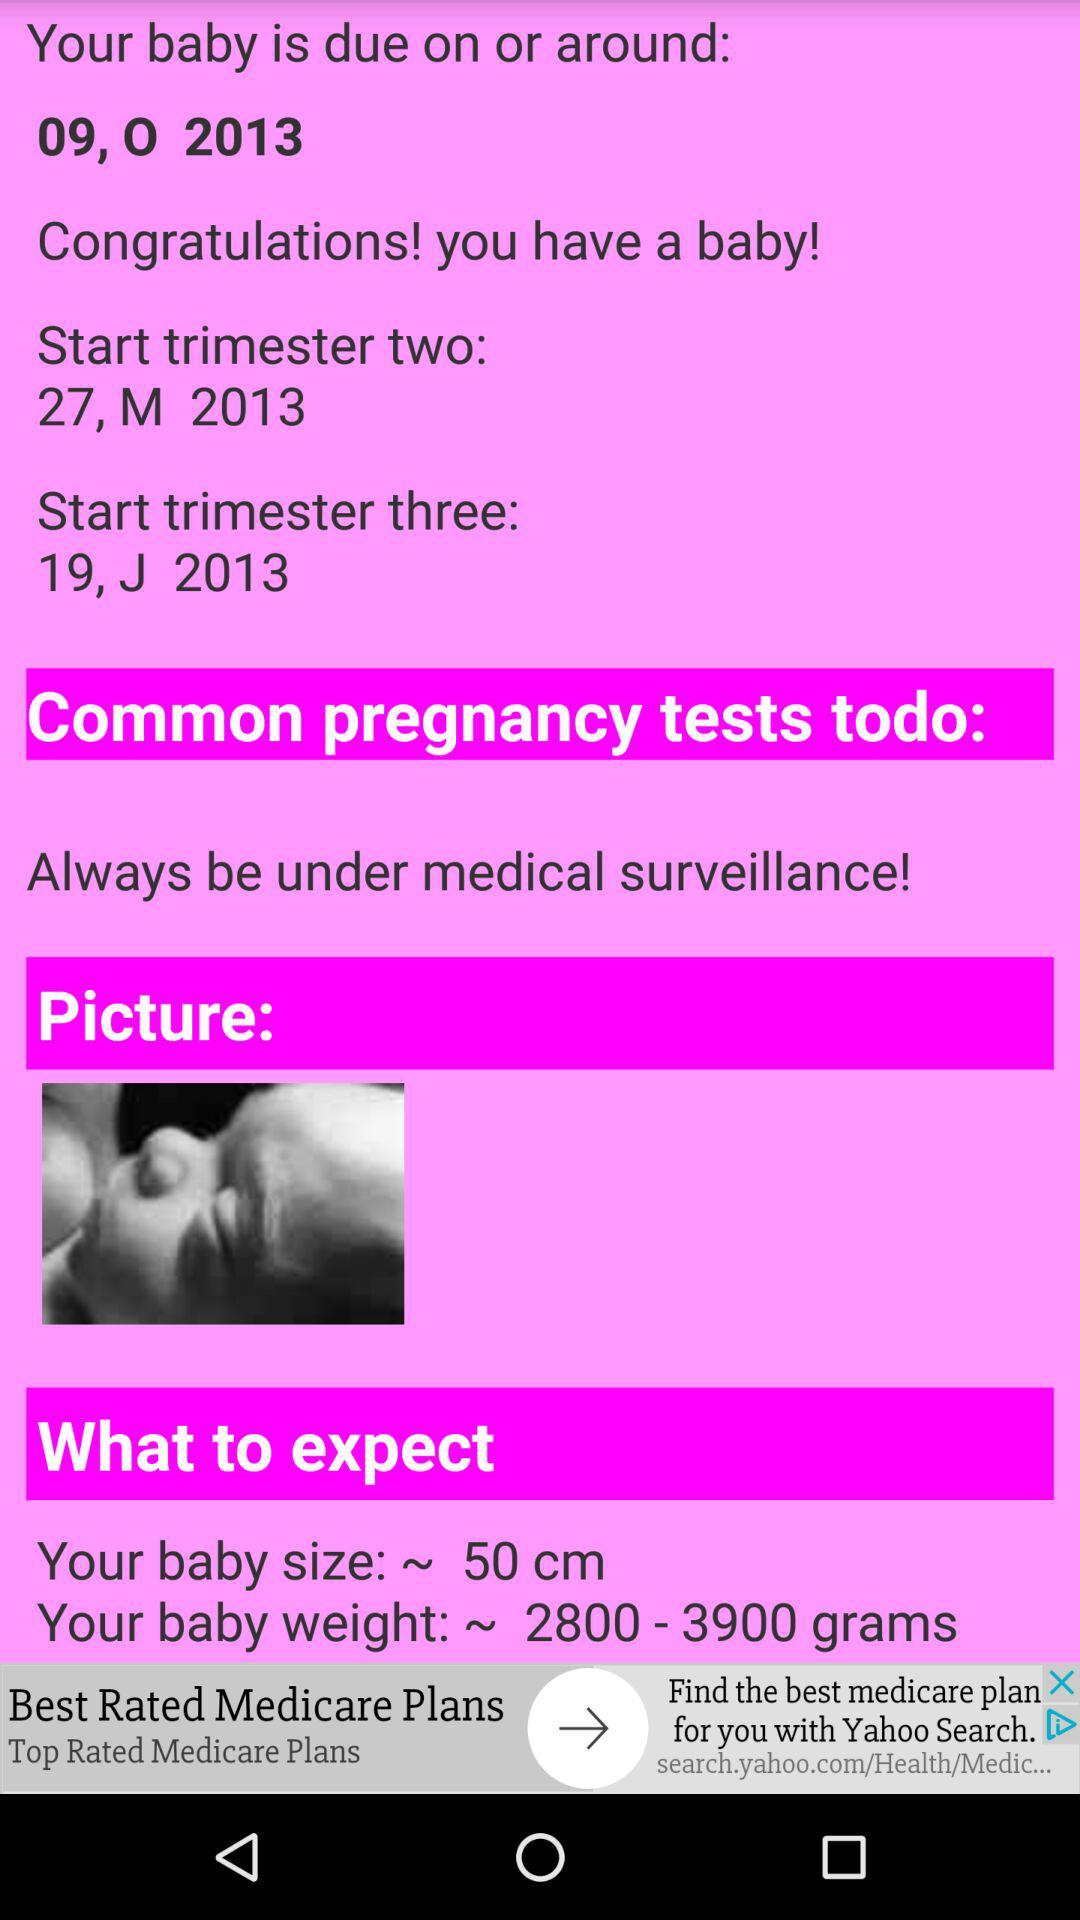What is the expected baby size? The expected baby size is 50 cm. 